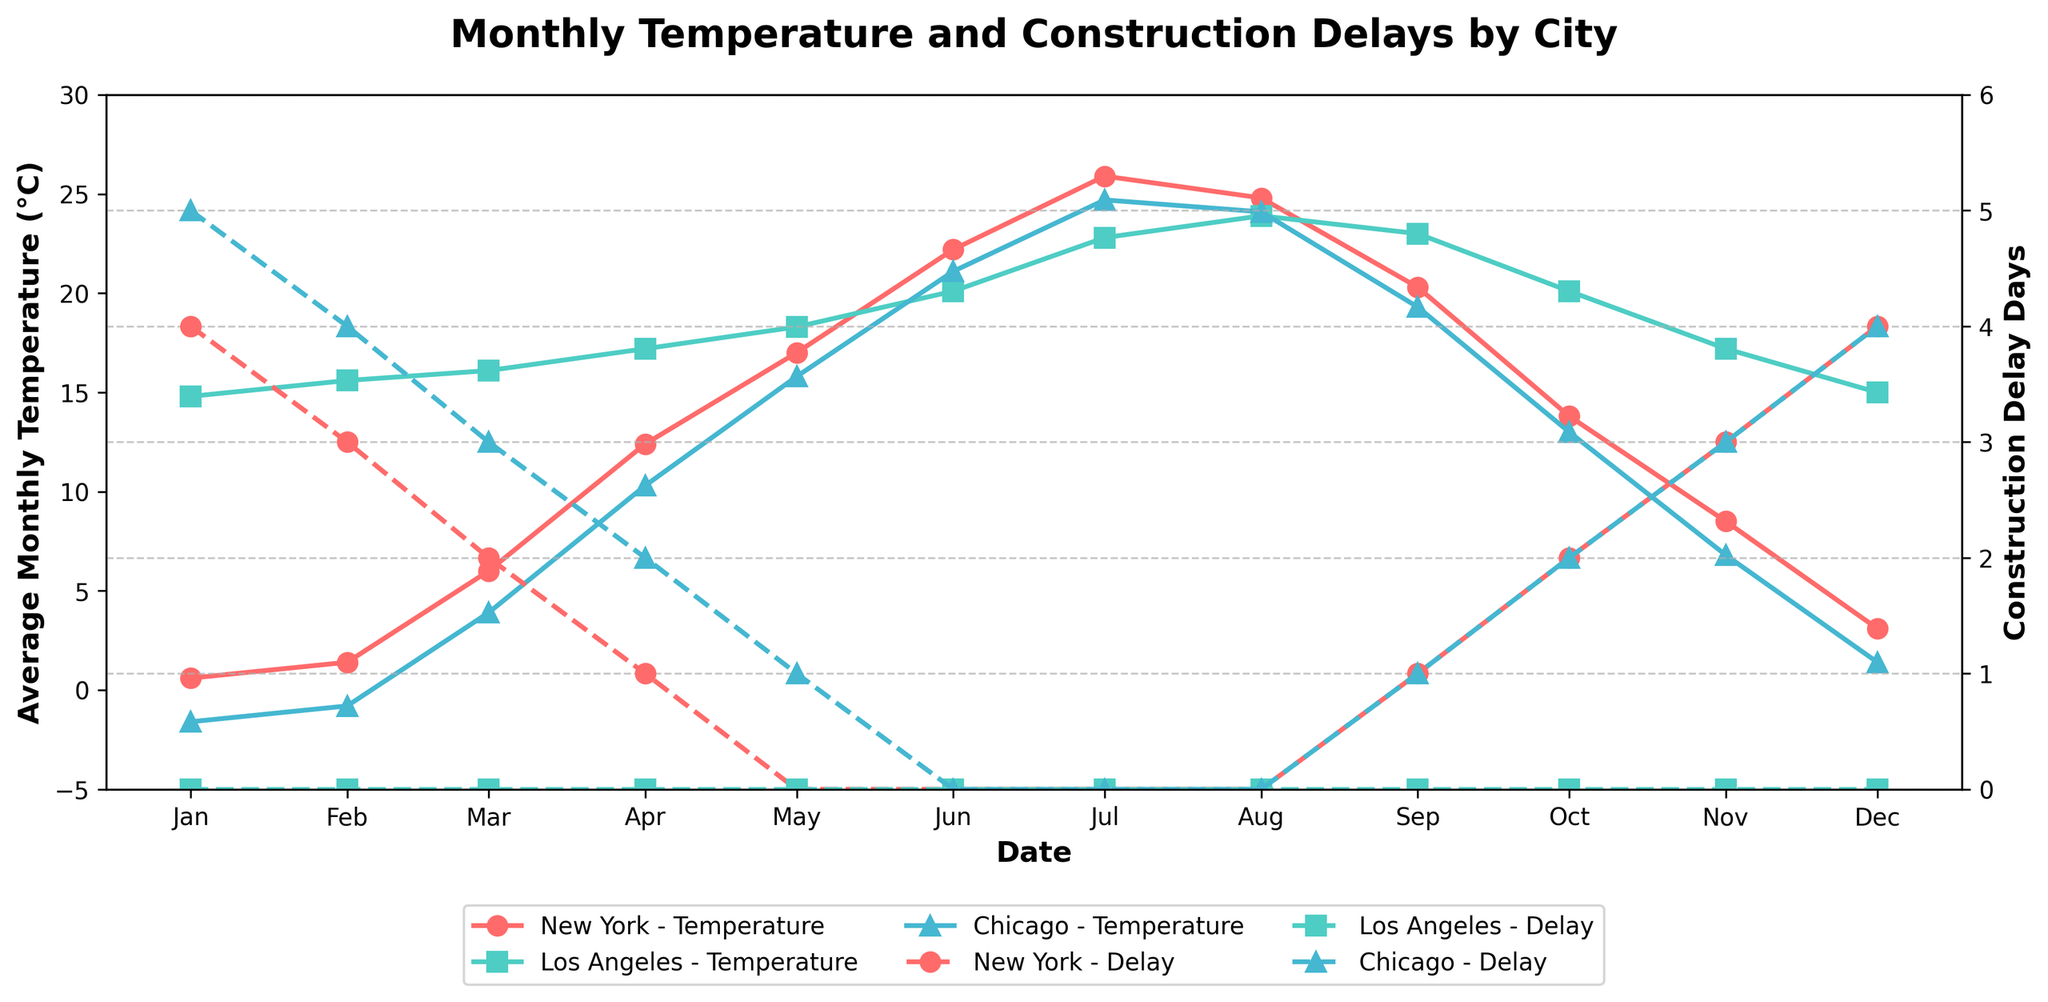What is the title of the plot? The title is typically displayed prominently at the top of the plot. It provides a brief description of the contents of the plot. In this case, it appears as "Monthly Temperature and Construction Delays by City".
Answer: Monthly Temperature and Construction Delays by City Which month in New York shows the highest average temperature? First, locate the New York line on the plot. Then, follow the line to find the month with the highest vertical position (temperature). July is the month when New York hits the highest temperature, which is 25.9°C.
Answer: July How many locations are depicted in the plot? Observe the plot and look for the unique markers or lines with different legends representing various locations. You will find three distinct locations: New York, Los Angeles, and Chicago.
Answer: 3 Which city had the highest construction delay in January? Identify the points representing January for each city on the secondary y-axis (construction delay days). For January, Chicago has the highest construction delay with 5 days, as indicated by the highest point in that month.
Answer: Chicago In which month does Chicago have zero construction delay days? Find the points representing Chicago and follow them to the months where "Construction Delay Days" is zero. For Chicago, this occurs in June, July, and August.
Answer: June, July, and August Compare the average temperature between New York and Los Angeles in April. Which city is warmer? Locate the April data points for both New York and Los Angeles on the primary y-axis (Average Monthly Temp, °C). In April, New York's temperature is 12.4°C, whereas Los Angeles' temperature is 17.2°C. Los Angeles is warmer.
Answer: Los Angeles What is the overall trend for construction delays in New York across the year? Identify the New York line for "Construction Delay Days" and observe its pattern throughout the year. It starts high in January (4 days), decreases continuously through the warmer months to zero in June to August, and then rises again towards the end of the year.
Answer: Decreases from Jan to Aug, then increases Which month in Chicago has the largest temperature increase compared to the previous month? Calculate the temperature difference month-by-month for Chicago. The largest increase is observed between February and March, increasing from -0.8°C to 3.9°C, which is a 4.7°C rise.
Answer: February to March Is there any month when Los Angeles experienced construction delays? By examining the construction delay line (secondary y-axis) for Los Angeles, note that it consistently stays at zero throughout the year indicating no delays.
Answer: No How do the temperature trends in New York and Chicago compare during summer months (June, July, August)? Evaluate the temperature lines for New York and Chicago during June, July, and August. Both cities exhibit similar trends: an initial rise in June to peak temperatures in July, followed by a slight decrease in August. This suggests a similar trend for summer months in both cities.
Answer: Similar trends 